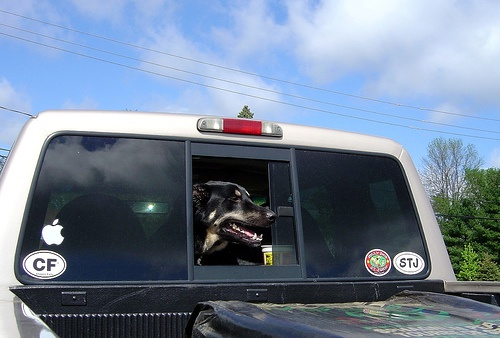Describe the objects in this image and their specific colors. I can see truck in lavender, black, gray, and white tones and dog in lavender, black, gray, and darkgray tones in this image. 